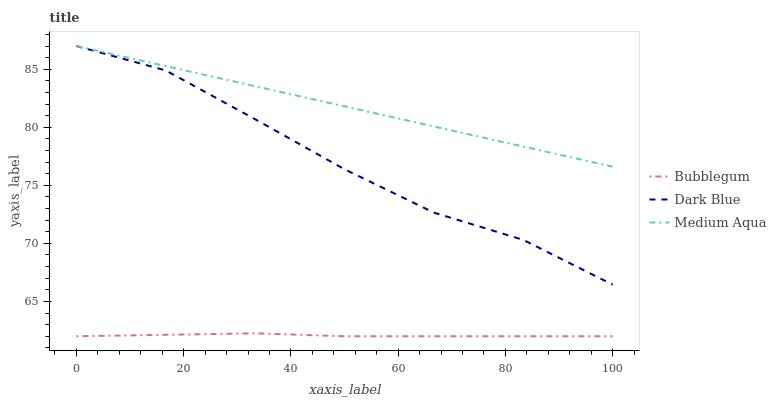Does Bubblegum have the minimum area under the curve?
Answer yes or no. Yes. Does Medium Aqua have the maximum area under the curve?
Answer yes or no. Yes. Does Medium Aqua have the minimum area under the curve?
Answer yes or no. No. Does Bubblegum have the maximum area under the curve?
Answer yes or no. No. Is Medium Aqua the smoothest?
Answer yes or no. Yes. Is Dark Blue the roughest?
Answer yes or no. Yes. Is Bubblegum the smoothest?
Answer yes or no. No. Is Bubblegum the roughest?
Answer yes or no. No. Does Bubblegum have the lowest value?
Answer yes or no. Yes. Does Medium Aqua have the lowest value?
Answer yes or no. No. Does Medium Aqua have the highest value?
Answer yes or no. Yes. Does Bubblegum have the highest value?
Answer yes or no. No. Is Bubblegum less than Dark Blue?
Answer yes or no. Yes. Is Medium Aqua greater than Bubblegum?
Answer yes or no. Yes. Does Medium Aqua intersect Dark Blue?
Answer yes or no. Yes. Is Medium Aqua less than Dark Blue?
Answer yes or no. No. Is Medium Aqua greater than Dark Blue?
Answer yes or no. No. Does Bubblegum intersect Dark Blue?
Answer yes or no. No. 